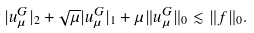<formula> <loc_0><loc_0><loc_500><loc_500>| u _ { \mu } ^ { G } | _ { 2 } + \sqrt { \mu } | u _ { \mu } ^ { G } | _ { 1 } + \mu \| u _ { \mu } ^ { G } \| _ { 0 } \lesssim \| f \| _ { 0 } .</formula> 